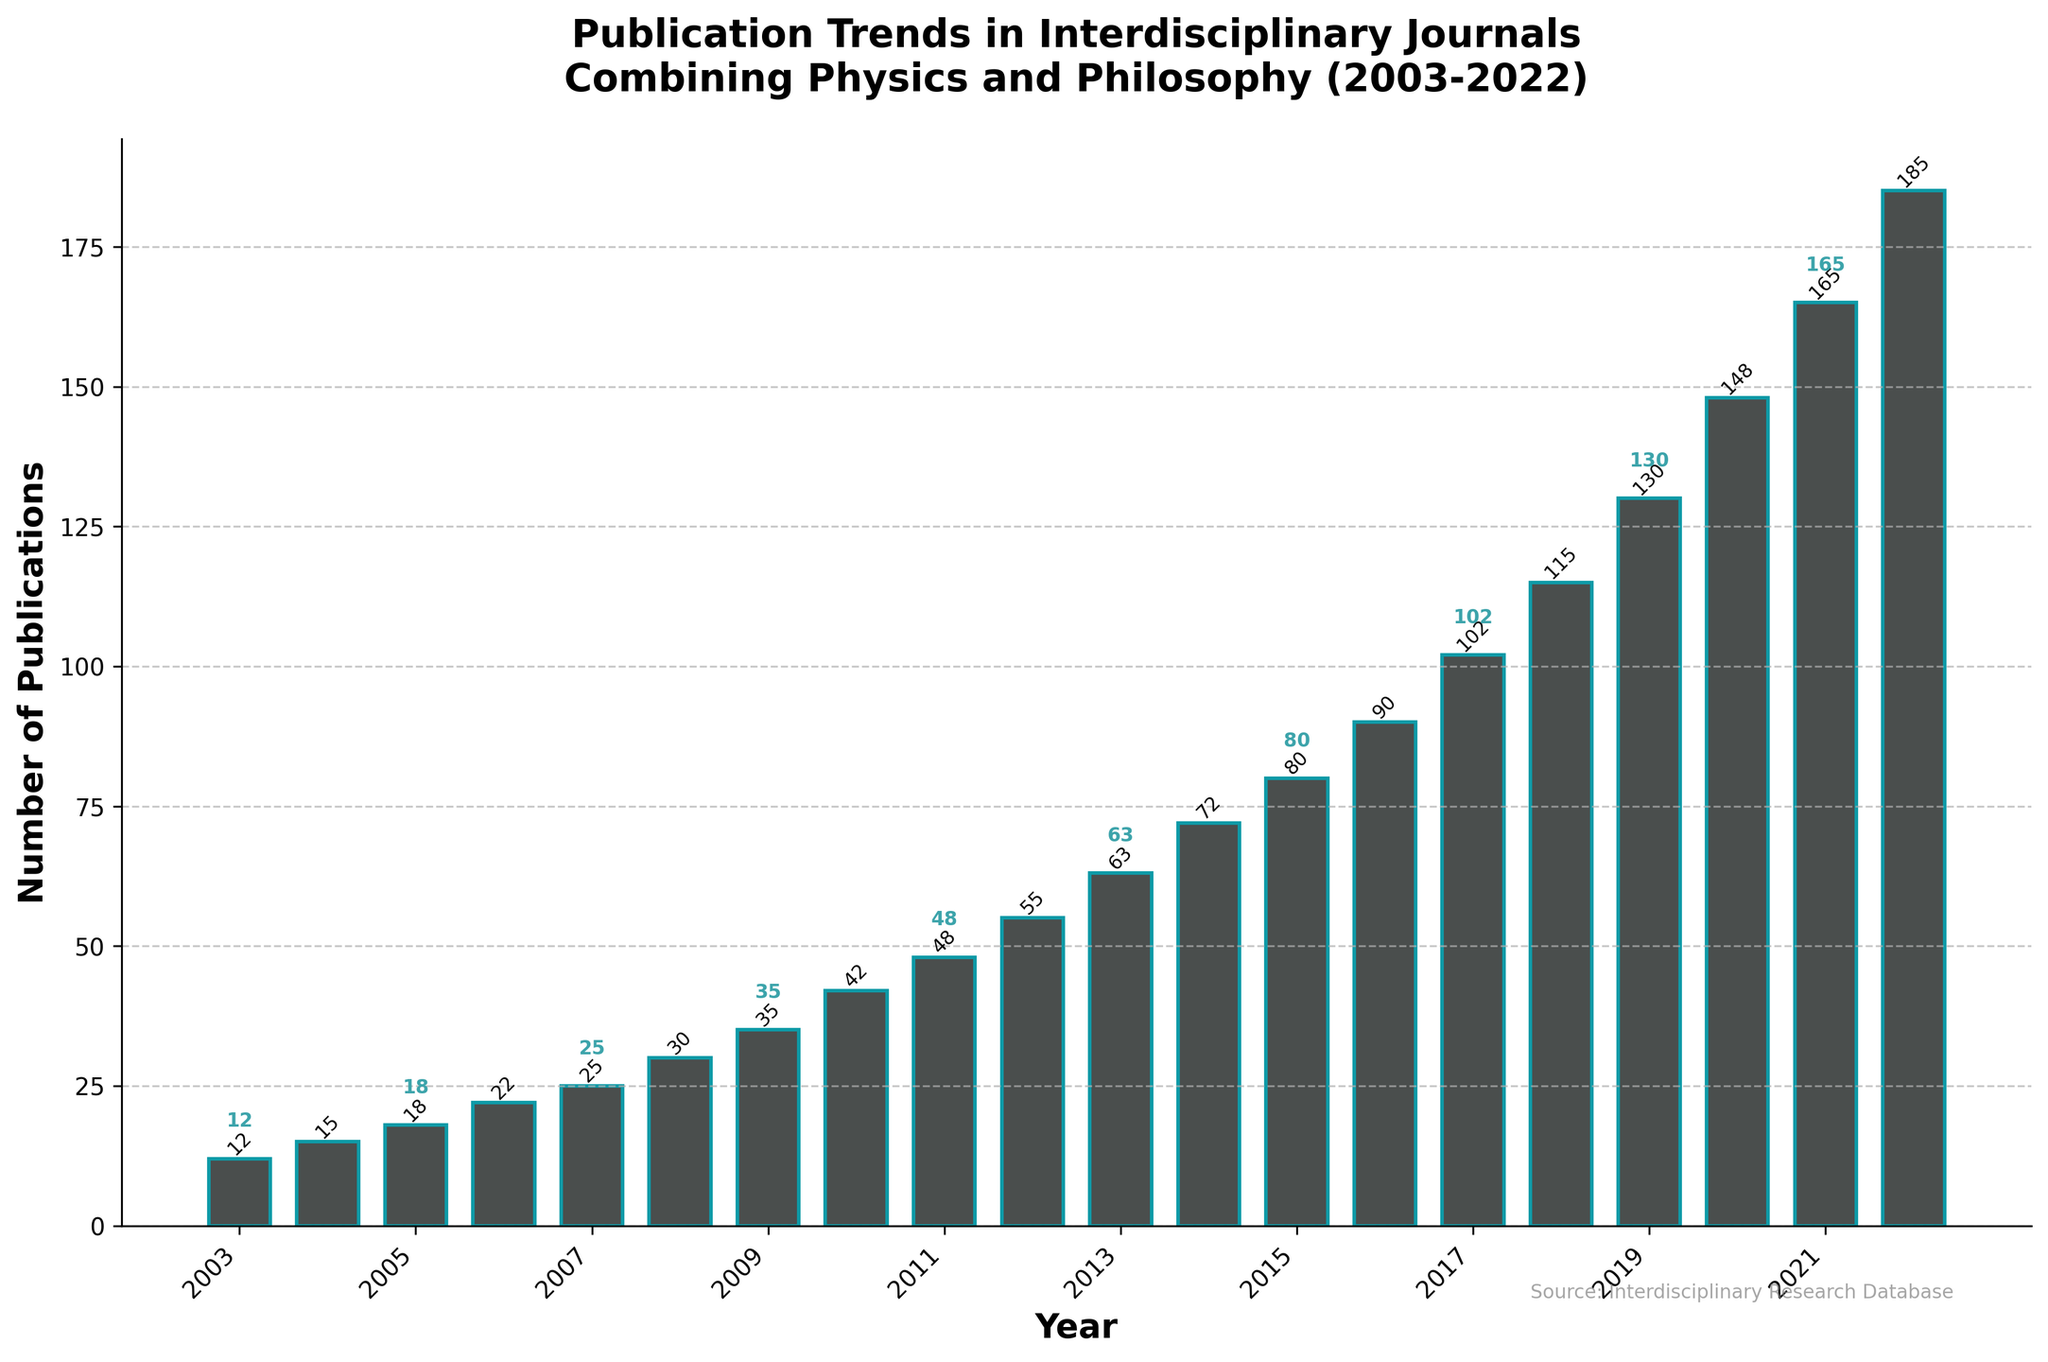What is the total number of publications in the years 2003 and 2022? To find the total number of publications in both years, add the values for each year. In 2003, there are 12 publications, and in 2022, there are 185 publications. So, 12 + 185 = 197
Answer: 197 Which year shows the highest number of publications on the chart? Look at the height of the bars and identify the tallest one. The highest bar corresponds to the year 2022, with 185 publications
Answer: 2022 What is the increase in the number of publications between 2003 and 2022? Subtract the number of publications in 2003 from those in 2022. In 2003, there are 12 publications, and in 2022, there are 185 publications. So, 185 - 12 = 173
Answer: 173 How does the number of publications in 2010 compare to that in 2015? Look at the heights of the bars for 2010 and 2015. In 2010, the number of publications is 42, and in 2015, it is 80. 42 is less than 80
Answer: 2010 has fewer publications than 2015 What is the average number of publications from 2003 to 2022? To find the average, sum all the publications from 2003 to 2022 and divide by the number of years. The sum is 1592, and there are 20 years. So, 1592 / 20 = 79.6
Answer: 79.6 Which two consecutive years show the largest increase in publications? Check the differences in publication numbers year by year, and identify the largest increase. Between 2019 (130) and 2020 (148), the difference is 18, which is the largest increase
Answer: Between 2019 and 2020 Is there a visible trend in the number of publications over the 20-year period? By observing the bars from left to right (2003 to 2022), we see a gradual increase in the height of the bars, indicating a continuous upward trend
Answer: Yes, there is an upward trend What is the difference in the number of publications between 2008 and 2013? Subtract the number of publications in 2008 from those in 2013. In 2008, there are 30 publications, and in 2013, there are 63. So, 63 - 30 = 33
Answer: 33 